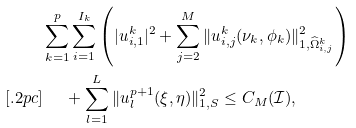Convert formula to latex. <formula><loc_0><loc_0><loc_500><loc_500>& \sum _ { k = 1 } ^ { p } \sum _ { i = 1 } ^ { I _ { k } } \left ( | u _ { i , 1 } ^ { k } | ^ { 2 } + \sum _ { j = 2 } ^ { M } \| u _ { i , j } ^ { k } ( \nu _ { k } , \phi _ { k } ) \| _ { 1 , \widehat { \Omega } _ { i , j } ^ { k } } ^ { 2 } \right ) \\ [ . 2 p c ] & \quad \ + \sum _ { l = 1 } ^ { L } \| u _ { l } ^ { p + 1 } ( \xi , \eta ) \| _ { 1 , S } ^ { 2 } \leq C _ { M } ( \mathcal { I } ) ,</formula> 